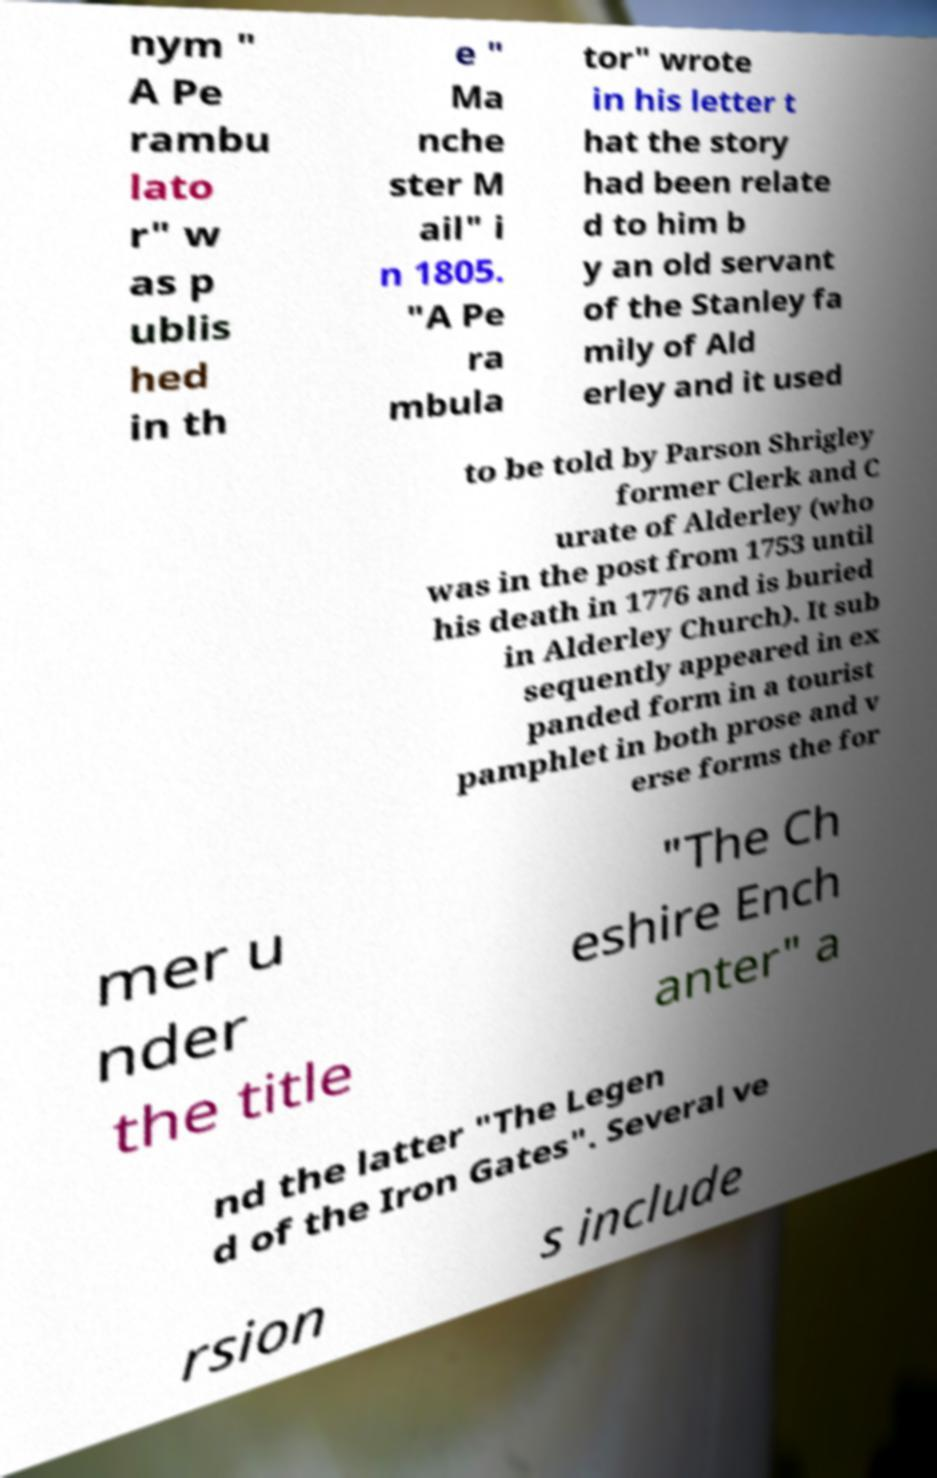Can you accurately transcribe the text from the provided image for me? nym " A Pe rambu lato r" w as p ublis hed in th e " Ma nche ster M ail" i n 1805. "A Pe ra mbula tor" wrote in his letter t hat the story had been relate d to him b y an old servant of the Stanley fa mily of Ald erley and it used to be told by Parson Shrigley former Clerk and C urate of Alderley (who was in the post from 1753 until his death in 1776 and is buried in Alderley Church). It sub sequently appeared in ex panded form in a tourist pamphlet in both prose and v erse forms the for mer u nder the title "The Ch eshire Ench anter" a nd the latter "The Legen d of the Iron Gates". Several ve rsion s include 